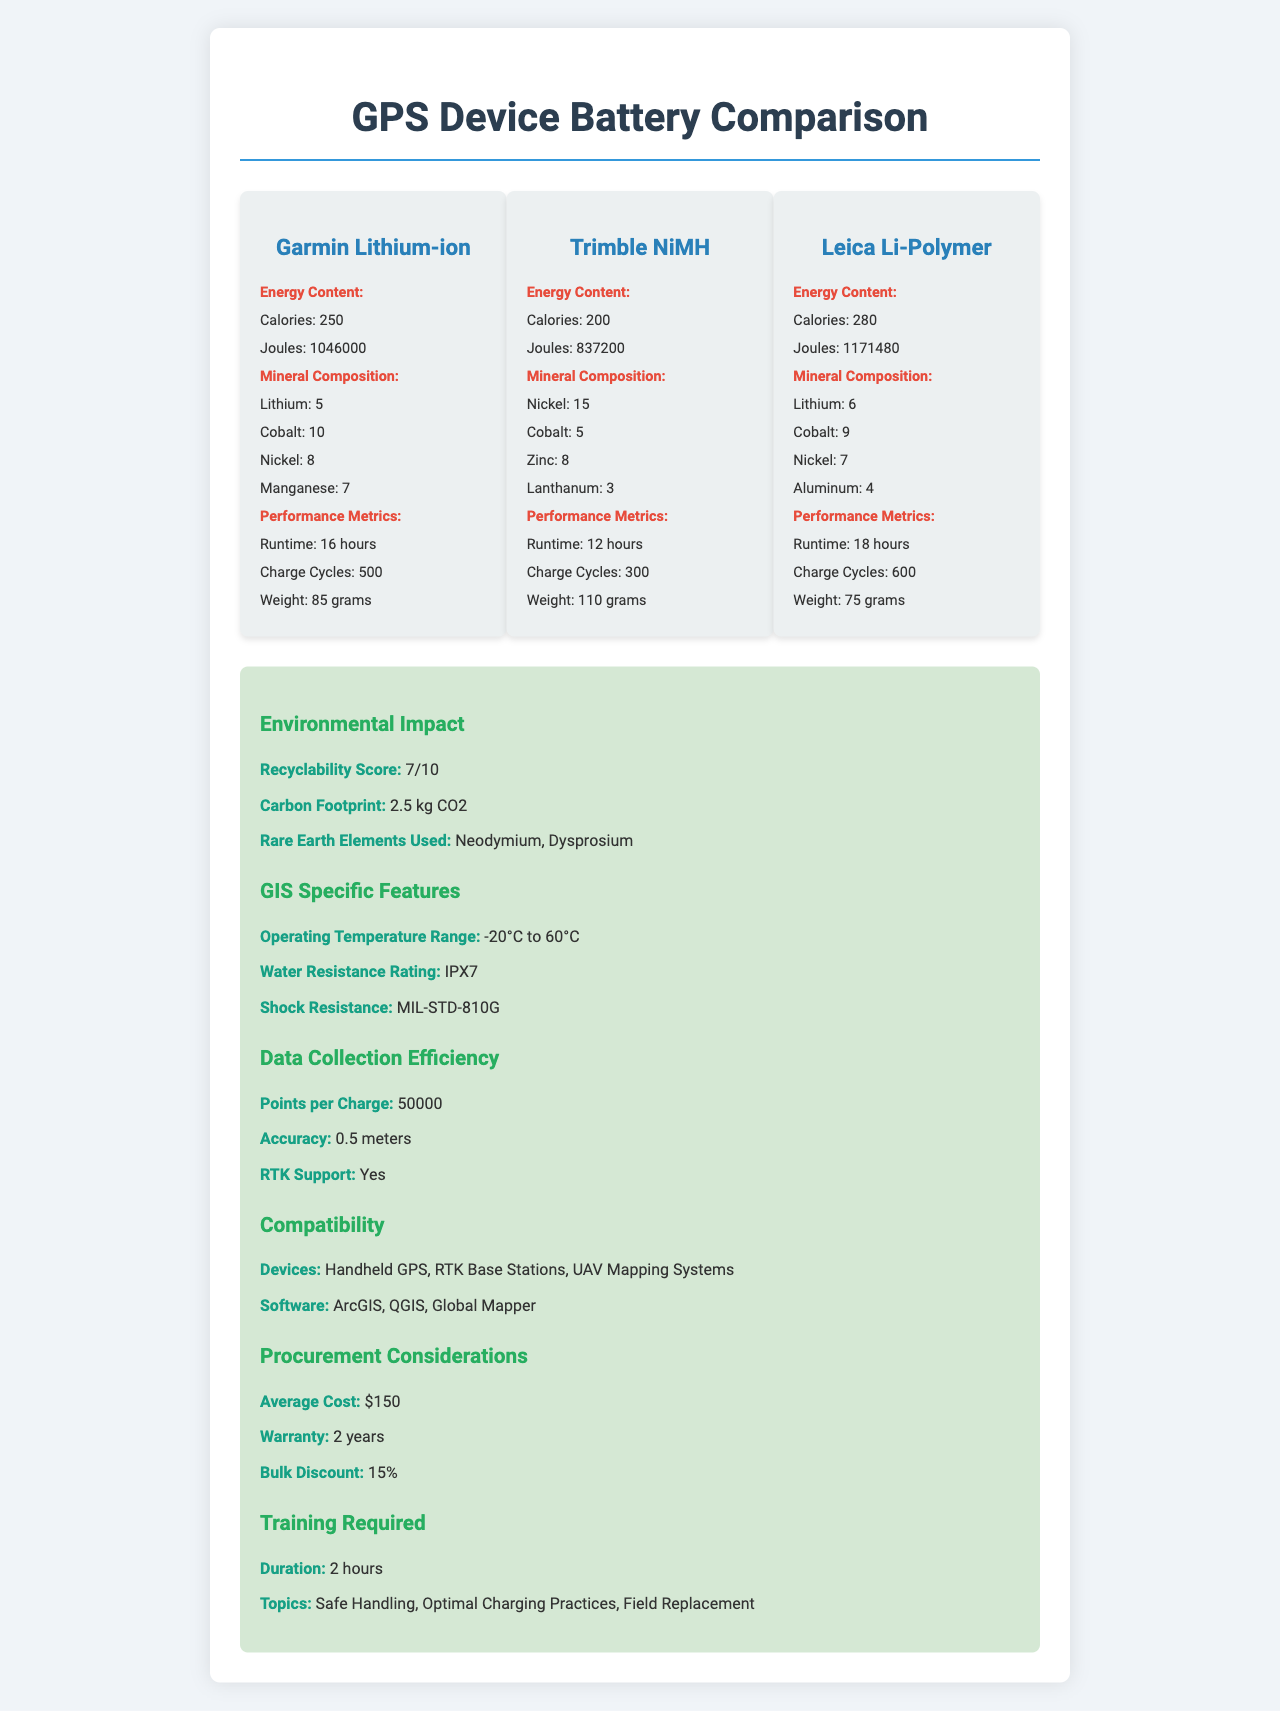who manufactures the Lithium-ion battery? The document lists the battery type "Garmin Lithium-ion", indicating Garmin as the manufacturer.
Answer: Garmin what is the runtime of the Trimble NiMH battery? Under the performance metrics section for the Trimble NiMH battery, it states "Runtime: 12 hours".
Answer: 12 hours how many charge cycles does the Leica Li-Polymer battery support? The performance metrics for the Leica Li-Polymer battery state "Charge Cycles: 600".
Answer: 600 which battery has the highest caloric energy content? The energy content section indicates the Leica Li-Polymer battery has 280 calories, which is the highest among the listed batteries.
Answer: Leica Li-Polymer what is the average cost of these GPS device batteries? The procurement considerations section states "Average Cost: $150".
Answer: $150 which battery weighs the least? A. Garmin Lithium-ion B. Trimble NiMH C. Leica Li-Polymer The performance metrics section lists the weights: Garmin Lithium-ion (85 grams), Trimble NiMH (110 grams), Leica Li-Polymer (75 grams). Leica Li-Polymer weighs the least.
Answer: C. Leica Li-Polymer what is the recyclability score of these batteries? A. 5 B. 7 C. 10 The environmental impact section mentions "Recyclability Score: 7/10".
Answer: B. 7 does the document mention the exact energy conversion efficiency of the batteries? The document lists energy content in calories and joules but does not provide specific details about energy conversion efficiency.
Answer: No is there RTK support for these GPS batteries? The data collection efficiency section states "RTK Support: Yes".
Answer: Yes summarize the main features described in this document. The document provides detailed comparisons and metrics for Garmin Lithium-ion, Trimble NiMH, and Leica Li-Polymer batteries, covering aspects such as runtime, charge cycles, weight, recyclability, operating temperature range, and procurement.
Answer: The document compares GPS device batteries, focusing on energy content, mineral composition, performance metrics, environmental impact, GIS-specific features, data collection efficiency, compatibility, procurement considerations, and training required. how many zinc units are present in the Garmin Lithium-ion battery? The document does not list zinc as a mineral component in the Garmin Lithium-ion battery.
Answer: Not enough information which battery has the lowest carbon footprint? The document provides a single carbon footprint score applicable to all battery types rather than individual scores.
Answer: Not enough information 